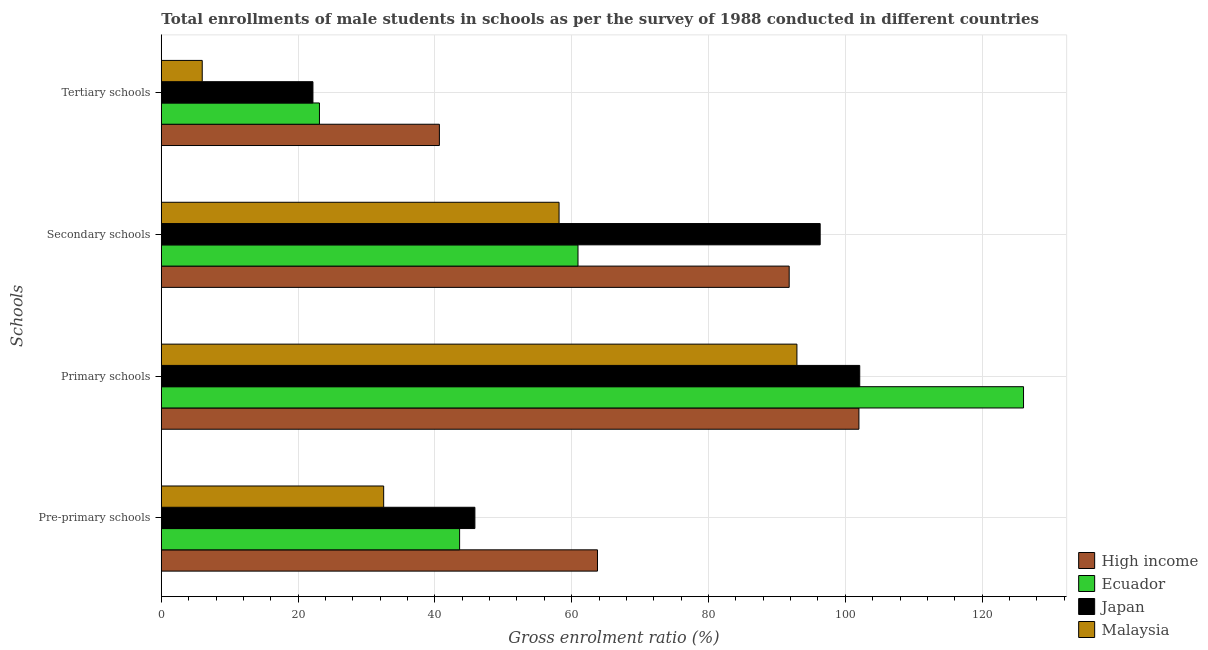How many different coloured bars are there?
Your answer should be very brief. 4. How many groups of bars are there?
Your answer should be very brief. 4. What is the label of the 3rd group of bars from the top?
Provide a short and direct response. Primary schools. What is the gross enrolment ratio(male) in primary schools in High income?
Offer a terse response. 101.99. Across all countries, what is the maximum gross enrolment ratio(male) in tertiary schools?
Make the answer very short. 40.65. Across all countries, what is the minimum gross enrolment ratio(male) in secondary schools?
Offer a terse response. 58.15. In which country was the gross enrolment ratio(male) in tertiary schools minimum?
Offer a terse response. Malaysia. What is the total gross enrolment ratio(male) in pre-primary schools in the graph?
Make the answer very short. 185.73. What is the difference between the gross enrolment ratio(male) in tertiary schools in Ecuador and that in Japan?
Provide a succinct answer. 0.95. What is the difference between the gross enrolment ratio(male) in secondary schools in Japan and the gross enrolment ratio(male) in primary schools in Malaysia?
Ensure brevity in your answer.  3.4. What is the average gross enrolment ratio(male) in secondary schools per country?
Keep it short and to the point. 76.8. What is the difference between the gross enrolment ratio(male) in tertiary schools and gross enrolment ratio(male) in primary schools in Japan?
Your answer should be compact. -79.94. What is the ratio of the gross enrolment ratio(male) in secondary schools in Ecuador to that in Malaysia?
Provide a succinct answer. 1.05. Is the difference between the gross enrolment ratio(male) in primary schools in Ecuador and Japan greater than the difference between the gross enrolment ratio(male) in tertiary schools in Ecuador and Japan?
Ensure brevity in your answer.  Yes. What is the difference between the highest and the second highest gross enrolment ratio(male) in pre-primary schools?
Your response must be concise. 17.92. What is the difference between the highest and the lowest gross enrolment ratio(male) in tertiary schools?
Provide a succinct answer. 34.67. In how many countries, is the gross enrolment ratio(male) in secondary schools greater than the average gross enrolment ratio(male) in secondary schools taken over all countries?
Your answer should be very brief. 2. Is it the case that in every country, the sum of the gross enrolment ratio(male) in pre-primary schools and gross enrolment ratio(male) in primary schools is greater than the sum of gross enrolment ratio(male) in tertiary schools and gross enrolment ratio(male) in secondary schools?
Make the answer very short. Yes. What does the 4th bar from the top in Secondary schools represents?
Give a very brief answer. High income. Is it the case that in every country, the sum of the gross enrolment ratio(male) in pre-primary schools and gross enrolment ratio(male) in primary schools is greater than the gross enrolment ratio(male) in secondary schools?
Provide a succinct answer. Yes. How many bars are there?
Ensure brevity in your answer.  16. Are all the bars in the graph horizontal?
Offer a very short reply. Yes. Does the graph contain any zero values?
Your response must be concise. No. How many legend labels are there?
Provide a short and direct response. 4. How are the legend labels stacked?
Your response must be concise. Vertical. What is the title of the graph?
Your answer should be compact. Total enrollments of male students in schools as per the survey of 1988 conducted in different countries. Does "Madagascar" appear as one of the legend labels in the graph?
Offer a terse response. No. What is the label or title of the Y-axis?
Your answer should be very brief. Schools. What is the Gross enrolment ratio (%) of High income in Pre-primary schools?
Your response must be concise. 63.77. What is the Gross enrolment ratio (%) of Ecuador in Pre-primary schools?
Give a very brief answer. 43.61. What is the Gross enrolment ratio (%) in Japan in Pre-primary schools?
Keep it short and to the point. 45.84. What is the Gross enrolment ratio (%) in Malaysia in Pre-primary schools?
Offer a very short reply. 32.51. What is the Gross enrolment ratio (%) of High income in Primary schools?
Your answer should be compact. 101.99. What is the Gross enrolment ratio (%) in Ecuador in Primary schools?
Your answer should be compact. 126.06. What is the Gross enrolment ratio (%) of Japan in Primary schools?
Make the answer very short. 102.11. What is the Gross enrolment ratio (%) in Malaysia in Primary schools?
Your answer should be very brief. 92.93. What is the Gross enrolment ratio (%) in High income in Secondary schools?
Keep it short and to the point. 91.8. What is the Gross enrolment ratio (%) of Ecuador in Secondary schools?
Offer a terse response. 60.92. What is the Gross enrolment ratio (%) of Japan in Secondary schools?
Keep it short and to the point. 96.33. What is the Gross enrolment ratio (%) of Malaysia in Secondary schools?
Your response must be concise. 58.15. What is the Gross enrolment ratio (%) of High income in Tertiary schools?
Offer a very short reply. 40.65. What is the Gross enrolment ratio (%) of Ecuador in Tertiary schools?
Offer a terse response. 23.12. What is the Gross enrolment ratio (%) of Japan in Tertiary schools?
Provide a succinct answer. 22.17. What is the Gross enrolment ratio (%) in Malaysia in Tertiary schools?
Provide a succinct answer. 5.98. Across all Schools, what is the maximum Gross enrolment ratio (%) in High income?
Your answer should be compact. 101.99. Across all Schools, what is the maximum Gross enrolment ratio (%) of Ecuador?
Your answer should be compact. 126.06. Across all Schools, what is the maximum Gross enrolment ratio (%) of Japan?
Keep it short and to the point. 102.11. Across all Schools, what is the maximum Gross enrolment ratio (%) of Malaysia?
Provide a short and direct response. 92.93. Across all Schools, what is the minimum Gross enrolment ratio (%) of High income?
Offer a terse response. 40.65. Across all Schools, what is the minimum Gross enrolment ratio (%) of Ecuador?
Provide a short and direct response. 23.12. Across all Schools, what is the minimum Gross enrolment ratio (%) of Japan?
Provide a short and direct response. 22.17. Across all Schools, what is the minimum Gross enrolment ratio (%) in Malaysia?
Your answer should be very brief. 5.98. What is the total Gross enrolment ratio (%) in High income in the graph?
Ensure brevity in your answer.  298.21. What is the total Gross enrolment ratio (%) in Ecuador in the graph?
Provide a short and direct response. 253.71. What is the total Gross enrolment ratio (%) of Japan in the graph?
Offer a very short reply. 266.45. What is the total Gross enrolment ratio (%) in Malaysia in the graph?
Make the answer very short. 189.57. What is the difference between the Gross enrolment ratio (%) in High income in Pre-primary schools and that in Primary schools?
Provide a short and direct response. -38.22. What is the difference between the Gross enrolment ratio (%) of Ecuador in Pre-primary schools and that in Primary schools?
Ensure brevity in your answer.  -82.45. What is the difference between the Gross enrolment ratio (%) of Japan in Pre-primary schools and that in Primary schools?
Provide a short and direct response. -56.27. What is the difference between the Gross enrolment ratio (%) in Malaysia in Pre-primary schools and that in Primary schools?
Offer a terse response. -60.42. What is the difference between the Gross enrolment ratio (%) of High income in Pre-primary schools and that in Secondary schools?
Make the answer very short. -28.03. What is the difference between the Gross enrolment ratio (%) in Ecuador in Pre-primary schools and that in Secondary schools?
Offer a very short reply. -17.31. What is the difference between the Gross enrolment ratio (%) of Japan in Pre-primary schools and that in Secondary schools?
Keep it short and to the point. -50.48. What is the difference between the Gross enrolment ratio (%) of Malaysia in Pre-primary schools and that in Secondary schools?
Ensure brevity in your answer.  -25.64. What is the difference between the Gross enrolment ratio (%) of High income in Pre-primary schools and that in Tertiary schools?
Offer a very short reply. 23.11. What is the difference between the Gross enrolment ratio (%) of Ecuador in Pre-primary schools and that in Tertiary schools?
Give a very brief answer. 20.49. What is the difference between the Gross enrolment ratio (%) in Japan in Pre-primary schools and that in Tertiary schools?
Your response must be concise. 23.68. What is the difference between the Gross enrolment ratio (%) in Malaysia in Pre-primary schools and that in Tertiary schools?
Make the answer very short. 26.53. What is the difference between the Gross enrolment ratio (%) in High income in Primary schools and that in Secondary schools?
Your response must be concise. 10.2. What is the difference between the Gross enrolment ratio (%) of Ecuador in Primary schools and that in Secondary schools?
Offer a very short reply. 65.14. What is the difference between the Gross enrolment ratio (%) of Japan in Primary schools and that in Secondary schools?
Give a very brief answer. 5.78. What is the difference between the Gross enrolment ratio (%) of Malaysia in Primary schools and that in Secondary schools?
Your response must be concise. 34.78. What is the difference between the Gross enrolment ratio (%) of High income in Primary schools and that in Tertiary schools?
Your answer should be compact. 61.34. What is the difference between the Gross enrolment ratio (%) of Ecuador in Primary schools and that in Tertiary schools?
Your answer should be compact. 102.94. What is the difference between the Gross enrolment ratio (%) of Japan in Primary schools and that in Tertiary schools?
Your response must be concise. 79.94. What is the difference between the Gross enrolment ratio (%) of Malaysia in Primary schools and that in Tertiary schools?
Your answer should be compact. 86.95. What is the difference between the Gross enrolment ratio (%) of High income in Secondary schools and that in Tertiary schools?
Your answer should be very brief. 51.14. What is the difference between the Gross enrolment ratio (%) of Ecuador in Secondary schools and that in Tertiary schools?
Your answer should be compact. 37.8. What is the difference between the Gross enrolment ratio (%) of Japan in Secondary schools and that in Tertiary schools?
Provide a short and direct response. 74.16. What is the difference between the Gross enrolment ratio (%) in Malaysia in Secondary schools and that in Tertiary schools?
Your answer should be very brief. 52.17. What is the difference between the Gross enrolment ratio (%) in High income in Pre-primary schools and the Gross enrolment ratio (%) in Ecuador in Primary schools?
Your answer should be very brief. -62.29. What is the difference between the Gross enrolment ratio (%) of High income in Pre-primary schools and the Gross enrolment ratio (%) of Japan in Primary schools?
Provide a succinct answer. -38.34. What is the difference between the Gross enrolment ratio (%) in High income in Pre-primary schools and the Gross enrolment ratio (%) in Malaysia in Primary schools?
Your response must be concise. -29.16. What is the difference between the Gross enrolment ratio (%) of Ecuador in Pre-primary schools and the Gross enrolment ratio (%) of Japan in Primary schools?
Give a very brief answer. -58.5. What is the difference between the Gross enrolment ratio (%) of Ecuador in Pre-primary schools and the Gross enrolment ratio (%) of Malaysia in Primary schools?
Your answer should be compact. -49.31. What is the difference between the Gross enrolment ratio (%) of Japan in Pre-primary schools and the Gross enrolment ratio (%) of Malaysia in Primary schools?
Offer a very short reply. -47.08. What is the difference between the Gross enrolment ratio (%) of High income in Pre-primary schools and the Gross enrolment ratio (%) of Ecuador in Secondary schools?
Your answer should be compact. 2.85. What is the difference between the Gross enrolment ratio (%) in High income in Pre-primary schools and the Gross enrolment ratio (%) in Japan in Secondary schools?
Your response must be concise. -32.56. What is the difference between the Gross enrolment ratio (%) of High income in Pre-primary schools and the Gross enrolment ratio (%) of Malaysia in Secondary schools?
Your answer should be compact. 5.62. What is the difference between the Gross enrolment ratio (%) in Ecuador in Pre-primary schools and the Gross enrolment ratio (%) in Japan in Secondary schools?
Offer a terse response. -52.71. What is the difference between the Gross enrolment ratio (%) of Ecuador in Pre-primary schools and the Gross enrolment ratio (%) of Malaysia in Secondary schools?
Provide a short and direct response. -14.54. What is the difference between the Gross enrolment ratio (%) of Japan in Pre-primary schools and the Gross enrolment ratio (%) of Malaysia in Secondary schools?
Provide a succinct answer. -12.31. What is the difference between the Gross enrolment ratio (%) in High income in Pre-primary schools and the Gross enrolment ratio (%) in Ecuador in Tertiary schools?
Your answer should be very brief. 40.65. What is the difference between the Gross enrolment ratio (%) of High income in Pre-primary schools and the Gross enrolment ratio (%) of Japan in Tertiary schools?
Your answer should be very brief. 41.6. What is the difference between the Gross enrolment ratio (%) of High income in Pre-primary schools and the Gross enrolment ratio (%) of Malaysia in Tertiary schools?
Offer a terse response. 57.79. What is the difference between the Gross enrolment ratio (%) of Ecuador in Pre-primary schools and the Gross enrolment ratio (%) of Japan in Tertiary schools?
Offer a terse response. 21.44. What is the difference between the Gross enrolment ratio (%) in Ecuador in Pre-primary schools and the Gross enrolment ratio (%) in Malaysia in Tertiary schools?
Offer a terse response. 37.63. What is the difference between the Gross enrolment ratio (%) in Japan in Pre-primary schools and the Gross enrolment ratio (%) in Malaysia in Tertiary schools?
Keep it short and to the point. 39.86. What is the difference between the Gross enrolment ratio (%) in High income in Primary schools and the Gross enrolment ratio (%) in Ecuador in Secondary schools?
Keep it short and to the point. 41.07. What is the difference between the Gross enrolment ratio (%) in High income in Primary schools and the Gross enrolment ratio (%) in Japan in Secondary schools?
Offer a terse response. 5.67. What is the difference between the Gross enrolment ratio (%) of High income in Primary schools and the Gross enrolment ratio (%) of Malaysia in Secondary schools?
Offer a terse response. 43.84. What is the difference between the Gross enrolment ratio (%) in Ecuador in Primary schools and the Gross enrolment ratio (%) in Japan in Secondary schools?
Your answer should be very brief. 29.73. What is the difference between the Gross enrolment ratio (%) of Ecuador in Primary schools and the Gross enrolment ratio (%) of Malaysia in Secondary schools?
Provide a short and direct response. 67.91. What is the difference between the Gross enrolment ratio (%) of Japan in Primary schools and the Gross enrolment ratio (%) of Malaysia in Secondary schools?
Provide a succinct answer. 43.96. What is the difference between the Gross enrolment ratio (%) of High income in Primary schools and the Gross enrolment ratio (%) of Ecuador in Tertiary schools?
Make the answer very short. 78.87. What is the difference between the Gross enrolment ratio (%) of High income in Primary schools and the Gross enrolment ratio (%) of Japan in Tertiary schools?
Offer a very short reply. 79.83. What is the difference between the Gross enrolment ratio (%) in High income in Primary schools and the Gross enrolment ratio (%) in Malaysia in Tertiary schools?
Offer a terse response. 96.01. What is the difference between the Gross enrolment ratio (%) in Ecuador in Primary schools and the Gross enrolment ratio (%) in Japan in Tertiary schools?
Your answer should be very brief. 103.89. What is the difference between the Gross enrolment ratio (%) of Ecuador in Primary schools and the Gross enrolment ratio (%) of Malaysia in Tertiary schools?
Your answer should be compact. 120.08. What is the difference between the Gross enrolment ratio (%) in Japan in Primary schools and the Gross enrolment ratio (%) in Malaysia in Tertiary schools?
Offer a terse response. 96.13. What is the difference between the Gross enrolment ratio (%) in High income in Secondary schools and the Gross enrolment ratio (%) in Ecuador in Tertiary schools?
Offer a terse response. 68.68. What is the difference between the Gross enrolment ratio (%) in High income in Secondary schools and the Gross enrolment ratio (%) in Japan in Tertiary schools?
Make the answer very short. 69.63. What is the difference between the Gross enrolment ratio (%) in High income in Secondary schools and the Gross enrolment ratio (%) in Malaysia in Tertiary schools?
Your answer should be very brief. 85.81. What is the difference between the Gross enrolment ratio (%) of Ecuador in Secondary schools and the Gross enrolment ratio (%) of Japan in Tertiary schools?
Provide a succinct answer. 38.75. What is the difference between the Gross enrolment ratio (%) in Ecuador in Secondary schools and the Gross enrolment ratio (%) in Malaysia in Tertiary schools?
Give a very brief answer. 54.94. What is the difference between the Gross enrolment ratio (%) of Japan in Secondary schools and the Gross enrolment ratio (%) of Malaysia in Tertiary schools?
Offer a very short reply. 90.35. What is the average Gross enrolment ratio (%) in High income per Schools?
Keep it short and to the point. 74.55. What is the average Gross enrolment ratio (%) in Ecuador per Schools?
Your answer should be very brief. 63.43. What is the average Gross enrolment ratio (%) in Japan per Schools?
Ensure brevity in your answer.  66.61. What is the average Gross enrolment ratio (%) in Malaysia per Schools?
Offer a terse response. 47.39. What is the difference between the Gross enrolment ratio (%) of High income and Gross enrolment ratio (%) of Ecuador in Pre-primary schools?
Keep it short and to the point. 20.16. What is the difference between the Gross enrolment ratio (%) in High income and Gross enrolment ratio (%) in Japan in Pre-primary schools?
Provide a short and direct response. 17.92. What is the difference between the Gross enrolment ratio (%) of High income and Gross enrolment ratio (%) of Malaysia in Pre-primary schools?
Offer a terse response. 31.26. What is the difference between the Gross enrolment ratio (%) in Ecuador and Gross enrolment ratio (%) in Japan in Pre-primary schools?
Make the answer very short. -2.23. What is the difference between the Gross enrolment ratio (%) in Ecuador and Gross enrolment ratio (%) in Malaysia in Pre-primary schools?
Give a very brief answer. 11.1. What is the difference between the Gross enrolment ratio (%) in Japan and Gross enrolment ratio (%) in Malaysia in Pre-primary schools?
Make the answer very short. 13.34. What is the difference between the Gross enrolment ratio (%) in High income and Gross enrolment ratio (%) in Ecuador in Primary schools?
Your answer should be compact. -24.07. What is the difference between the Gross enrolment ratio (%) in High income and Gross enrolment ratio (%) in Japan in Primary schools?
Make the answer very short. -0.12. What is the difference between the Gross enrolment ratio (%) in High income and Gross enrolment ratio (%) in Malaysia in Primary schools?
Offer a terse response. 9.07. What is the difference between the Gross enrolment ratio (%) of Ecuador and Gross enrolment ratio (%) of Japan in Primary schools?
Your answer should be very brief. 23.95. What is the difference between the Gross enrolment ratio (%) of Ecuador and Gross enrolment ratio (%) of Malaysia in Primary schools?
Make the answer very short. 33.13. What is the difference between the Gross enrolment ratio (%) in Japan and Gross enrolment ratio (%) in Malaysia in Primary schools?
Make the answer very short. 9.18. What is the difference between the Gross enrolment ratio (%) in High income and Gross enrolment ratio (%) in Ecuador in Secondary schools?
Your answer should be very brief. 30.88. What is the difference between the Gross enrolment ratio (%) in High income and Gross enrolment ratio (%) in Japan in Secondary schools?
Give a very brief answer. -4.53. What is the difference between the Gross enrolment ratio (%) of High income and Gross enrolment ratio (%) of Malaysia in Secondary schools?
Your answer should be very brief. 33.65. What is the difference between the Gross enrolment ratio (%) of Ecuador and Gross enrolment ratio (%) of Japan in Secondary schools?
Your response must be concise. -35.41. What is the difference between the Gross enrolment ratio (%) in Ecuador and Gross enrolment ratio (%) in Malaysia in Secondary schools?
Make the answer very short. 2.77. What is the difference between the Gross enrolment ratio (%) in Japan and Gross enrolment ratio (%) in Malaysia in Secondary schools?
Provide a succinct answer. 38.18. What is the difference between the Gross enrolment ratio (%) of High income and Gross enrolment ratio (%) of Ecuador in Tertiary schools?
Offer a very short reply. 17.53. What is the difference between the Gross enrolment ratio (%) of High income and Gross enrolment ratio (%) of Japan in Tertiary schools?
Offer a terse response. 18.49. What is the difference between the Gross enrolment ratio (%) in High income and Gross enrolment ratio (%) in Malaysia in Tertiary schools?
Provide a succinct answer. 34.67. What is the difference between the Gross enrolment ratio (%) of Ecuador and Gross enrolment ratio (%) of Japan in Tertiary schools?
Your answer should be compact. 0.95. What is the difference between the Gross enrolment ratio (%) in Ecuador and Gross enrolment ratio (%) in Malaysia in Tertiary schools?
Your answer should be compact. 17.14. What is the difference between the Gross enrolment ratio (%) of Japan and Gross enrolment ratio (%) of Malaysia in Tertiary schools?
Your answer should be compact. 16.19. What is the ratio of the Gross enrolment ratio (%) in High income in Pre-primary schools to that in Primary schools?
Your answer should be compact. 0.63. What is the ratio of the Gross enrolment ratio (%) of Ecuador in Pre-primary schools to that in Primary schools?
Offer a very short reply. 0.35. What is the ratio of the Gross enrolment ratio (%) in Japan in Pre-primary schools to that in Primary schools?
Offer a very short reply. 0.45. What is the ratio of the Gross enrolment ratio (%) in Malaysia in Pre-primary schools to that in Primary schools?
Your answer should be very brief. 0.35. What is the ratio of the Gross enrolment ratio (%) of High income in Pre-primary schools to that in Secondary schools?
Provide a succinct answer. 0.69. What is the ratio of the Gross enrolment ratio (%) of Ecuador in Pre-primary schools to that in Secondary schools?
Offer a terse response. 0.72. What is the ratio of the Gross enrolment ratio (%) in Japan in Pre-primary schools to that in Secondary schools?
Provide a short and direct response. 0.48. What is the ratio of the Gross enrolment ratio (%) in Malaysia in Pre-primary schools to that in Secondary schools?
Make the answer very short. 0.56. What is the ratio of the Gross enrolment ratio (%) of High income in Pre-primary schools to that in Tertiary schools?
Keep it short and to the point. 1.57. What is the ratio of the Gross enrolment ratio (%) of Ecuador in Pre-primary schools to that in Tertiary schools?
Your response must be concise. 1.89. What is the ratio of the Gross enrolment ratio (%) in Japan in Pre-primary schools to that in Tertiary schools?
Keep it short and to the point. 2.07. What is the ratio of the Gross enrolment ratio (%) in Malaysia in Pre-primary schools to that in Tertiary schools?
Make the answer very short. 5.43. What is the ratio of the Gross enrolment ratio (%) of Ecuador in Primary schools to that in Secondary schools?
Offer a very short reply. 2.07. What is the ratio of the Gross enrolment ratio (%) in Japan in Primary schools to that in Secondary schools?
Give a very brief answer. 1.06. What is the ratio of the Gross enrolment ratio (%) of Malaysia in Primary schools to that in Secondary schools?
Give a very brief answer. 1.6. What is the ratio of the Gross enrolment ratio (%) in High income in Primary schools to that in Tertiary schools?
Offer a very short reply. 2.51. What is the ratio of the Gross enrolment ratio (%) in Ecuador in Primary schools to that in Tertiary schools?
Provide a succinct answer. 5.45. What is the ratio of the Gross enrolment ratio (%) of Japan in Primary schools to that in Tertiary schools?
Your answer should be compact. 4.61. What is the ratio of the Gross enrolment ratio (%) of Malaysia in Primary schools to that in Tertiary schools?
Give a very brief answer. 15.54. What is the ratio of the Gross enrolment ratio (%) of High income in Secondary schools to that in Tertiary schools?
Provide a succinct answer. 2.26. What is the ratio of the Gross enrolment ratio (%) of Ecuador in Secondary schools to that in Tertiary schools?
Offer a terse response. 2.63. What is the ratio of the Gross enrolment ratio (%) in Japan in Secondary schools to that in Tertiary schools?
Make the answer very short. 4.35. What is the ratio of the Gross enrolment ratio (%) of Malaysia in Secondary schools to that in Tertiary schools?
Make the answer very short. 9.72. What is the difference between the highest and the second highest Gross enrolment ratio (%) of High income?
Offer a terse response. 10.2. What is the difference between the highest and the second highest Gross enrolment ratio (%) of Ecuador?
Offer a terse response. 65.14. What is the difference between the highest and the second highest Gross enrolment ratio (%) of Japan?
Provide a short and direct response. 5.78. What is the difference between the highest and the second highest Gross enrolment ratio (%) in Malaysia?
Your answer should be compact. 34.78. What is the difference between the highest and the lowest Gross enrolment ratio (%) in High income?
Make the answer very short. 61.34. What is the difference between the highest and the lowest Gross enrolment ratio (%) in Ecuador?
Your answer should be compact. 102.94. What is the difference between the highest and the lowest Gross enrolment ratio (%) of Japan?
Keep it short and to the point. 79.94. What is the difference between the highest and the lowest Gross enrolment ratio (%) in Malaysia?
Offer a terse response. 86.95. 